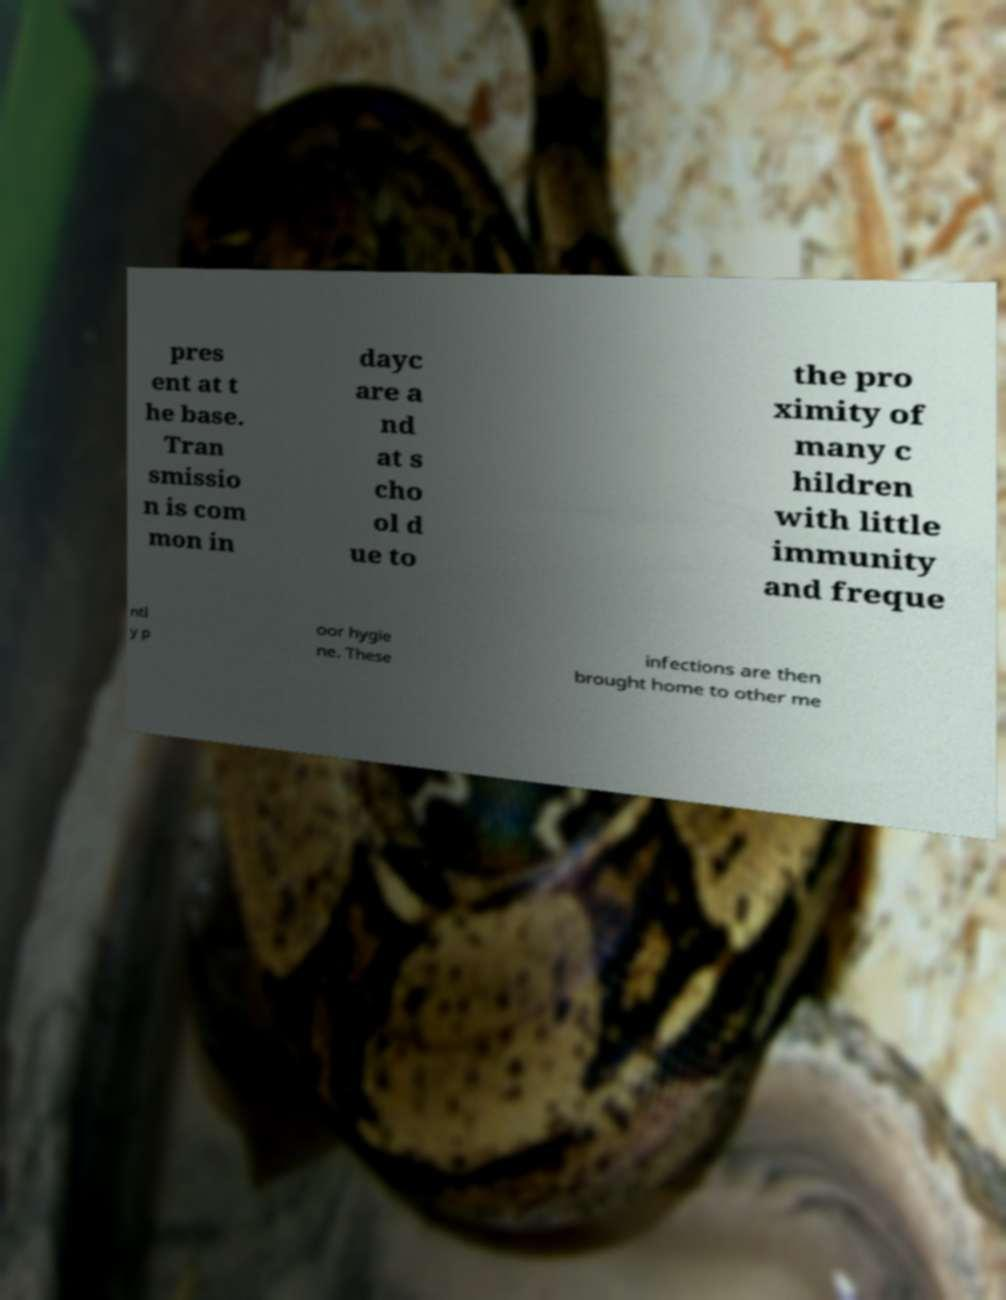Can you read and provide the text displayed in the image?This photo seems to have some interesting text. Can you extract and type it out for me? pres ent at t he base. Tran smissio n is com mon in dayc are a nd at s cho ol d ue to the pro ximity of many c hildren with little immunity and freque ntl y p oor hygie ne. These infections are then brought home to other me 